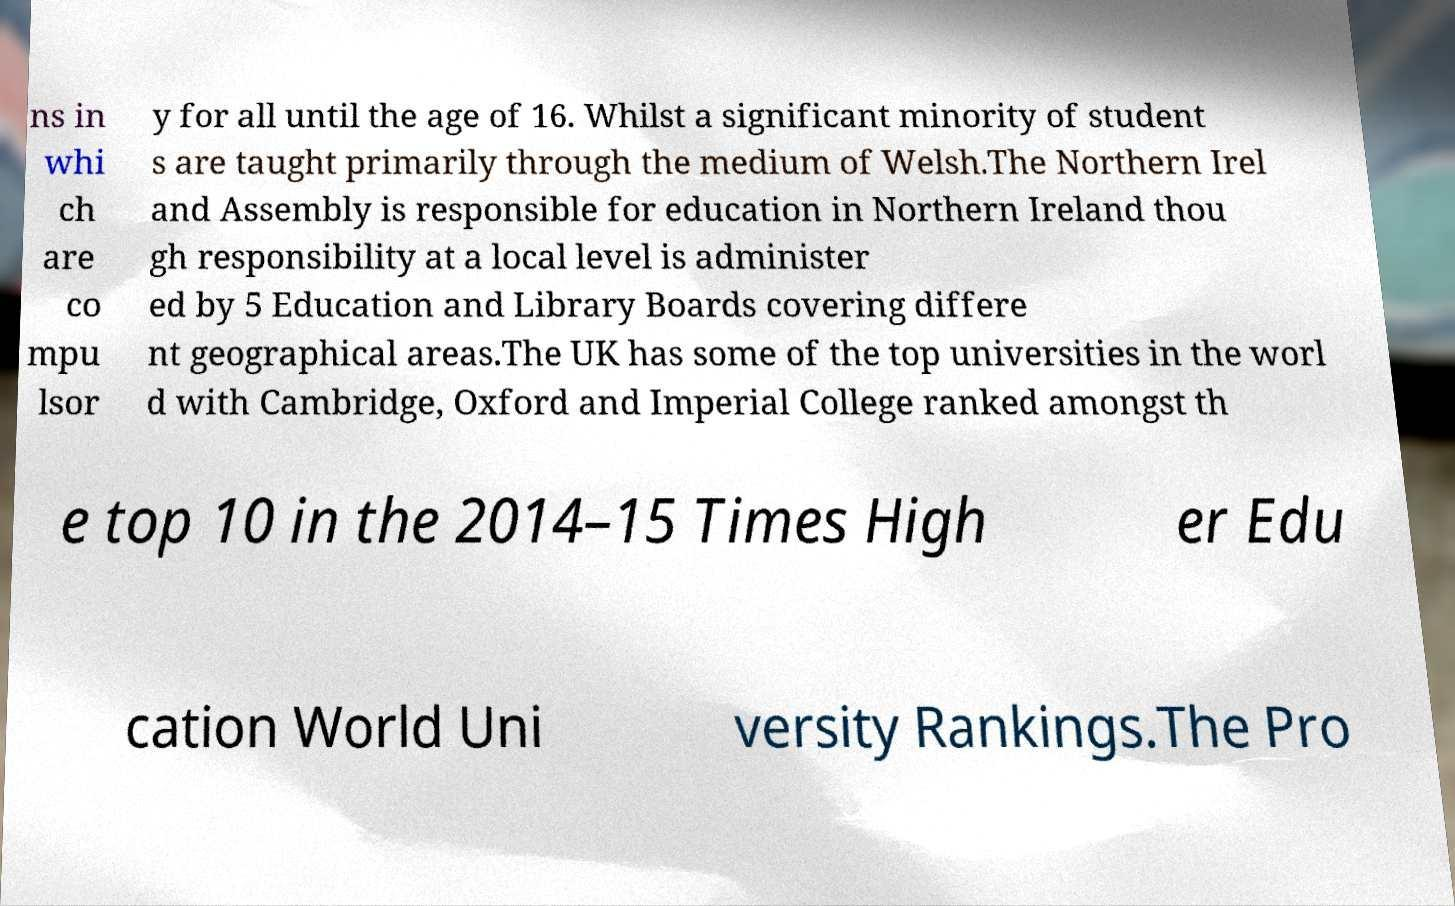Please identify and transcribe the text found in this image. ns in whi ch are co mpu lsor y for all until the age of 16. Whilst a significant minority of student s are taught primarily through the medium of Welsh.The Northern Irel and Assembly is responsible for education in Northern Ireland thou gh responsibility at a local level is administer ed by 5 Education and Library Boards covering differe nt geographical areas.The UK has some of the top universities in the worl d with Cambridge, Oxford and Imperial College ranked amongst th e top 10 in the 2014–15 Times High er Edu cation World Uni versity Rankings.The Pro 